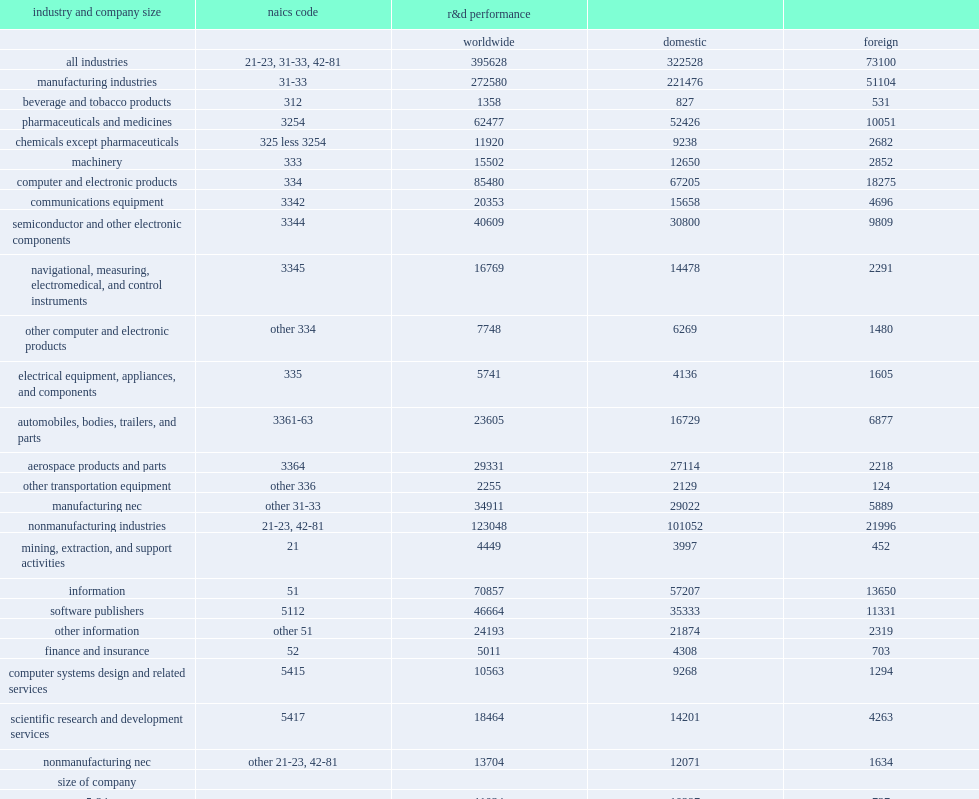Could you parse the entire table? {'header': ['industry and company size', 'naics code', 'r&d performance', '', ''], 'rows': [['', '', 'worldwide', 'domestic', 'foreign'], ['all industries', '21-23, 31-33, 42-81', '395628', '322528', '73100'], ['manufacturing industries', '31-33', '272580', '221476', '51104'], ['beverage and tobacco products', '312', '1358', '827', '531'], ['pharmaceuticals and medicines', '3254', '62477', '52426', '10051'], ['chemicals except pharmaceuticals', '325 less 3254', '11920', '9238', '2682'], ['machinery', '333', '15502', '12650', '2852'], ['computer and electronic products', '334', '85480', '67205', '18275'], ['communications equipment', '3342', '20353', '15658', '4696'], ['semiconductor and other electronic components', '3344', '40609', '30800', '9809'], ['navigational, measuring, electromedical, and control instruments', '3345', '16769', '14478', '2291'], ['other computer and electronic products', 'other 334', '7748', '6269', '1480'], ['electrical equipment, appliances, and components', '335', '5741', '4136', '1605'], ['automobiles, bodies, trailers, and parts', '3361-63', '23605', '16729', '6877'], ['aerospace products and parts', '3364', '29331', '27114', '2218'], ['other transportation equipment', 'other 336', '2255', '2129', '124'], ['manufacturing nec', 'other 31-33', '34911', '29022', '5889'], ['nonmanufacturing industries', '21-23, 42-81', '123048', '101052', '21996'], ['mining, extraction, and support activities', '21', '4449', '3997', '452'], ['information', '51', '70857', '57207', '13650'], ['software publishers', '5112', '46664', '35333', '11331'], ['other information', 'other 51', '24193', '21874', '2319'], ['finance and insurance', '52', '5011', '4308', '703'], ['computer systems design and related services', '5415', '10563', '9268', '1294'], ['scientific research and development services', '5417', '18464', '14201', '4263'], ['nonmanufacturing nec', 'other 21-23, 42-81', '13704', '12071', '1634'], ['size of company', '', '', '', ''], ['5-24', '-', '11034', '10297', '737'], ['25-49', '-', '8381', '7941', '440'], ['50-99', '-', '9254', '8910', '344'], ['100-249', '-', '14941', '13666', '1275'], ['250-499', '-', '13562', '12189', '1373'], ['500-999', '-', '13658', '12002', '1656'], ['1,000-4,999', '-', '69097', '55517', '13580'], ['5,000-9,999', '-', '42350', '31514', '10836'], ['10,000-24,999', '-', '60999', '51218', '9782'], ['25,000 or more', '-', '152351', '119275', '33076']]} How many million dollars did u.s. companies perform in research and development outside the united states in 2013? 73100.0. How many million dollars did u.s. companies perform in r&d in the united states? 322528.0. 